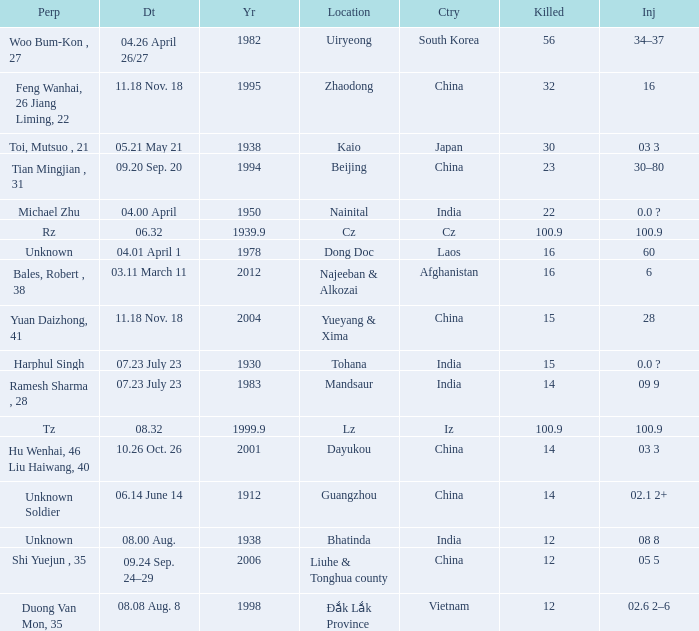What is Injured, when Country is "Afghanistan"? 6.0. 